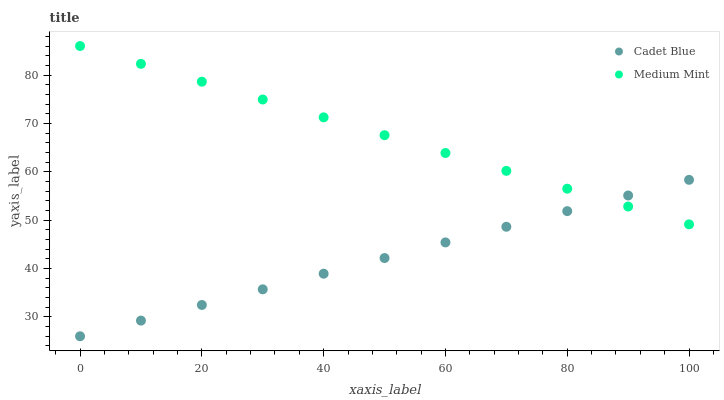Does Cadet Blue have the minimum area under the curve?
Answer yes or no. Yes. Does Medium Mint have the maximum area under the curve?
Answer yes or no. Yes. Does Cadet Blue have the maximum area under the curve?
Answer yes or no. No. Is Cadet Blue the smoothest?
Answer yes or no. Yes. Is Medium Mint the roughest?
Answer yes or no. Yes. Is Cadet Blue the roughest?
Answer yes or no. No. Does Cadet Blue have the lowest value?
Answer yes or no. Yes. Does Medium Mint have the highest value?
Answer yes or no. Yes. Does Cadet Blue have the highest value?
Answer yes or no. No. Does Medium Mint intersect Cadet Blue?
Answer yes or no. Yes. Is Medium Mint less than Cadet Blue?
Answer yes or no. No. Is Medium Mint greater than Cadet Blue?
Answer yes or no. No. 